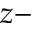<formula> <loc_0><loc_0><loc_500><loc_500>z -</formula> 